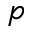<formula> <loc_0><loc_0><loc_500><loc_500>p</formula> 